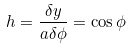Convert formula to latex. <formula><loc_0><loc_0><loc_500><loc_500>h = \frac { \delta y } { a \delta \phi } = \cos \phi</formula> 